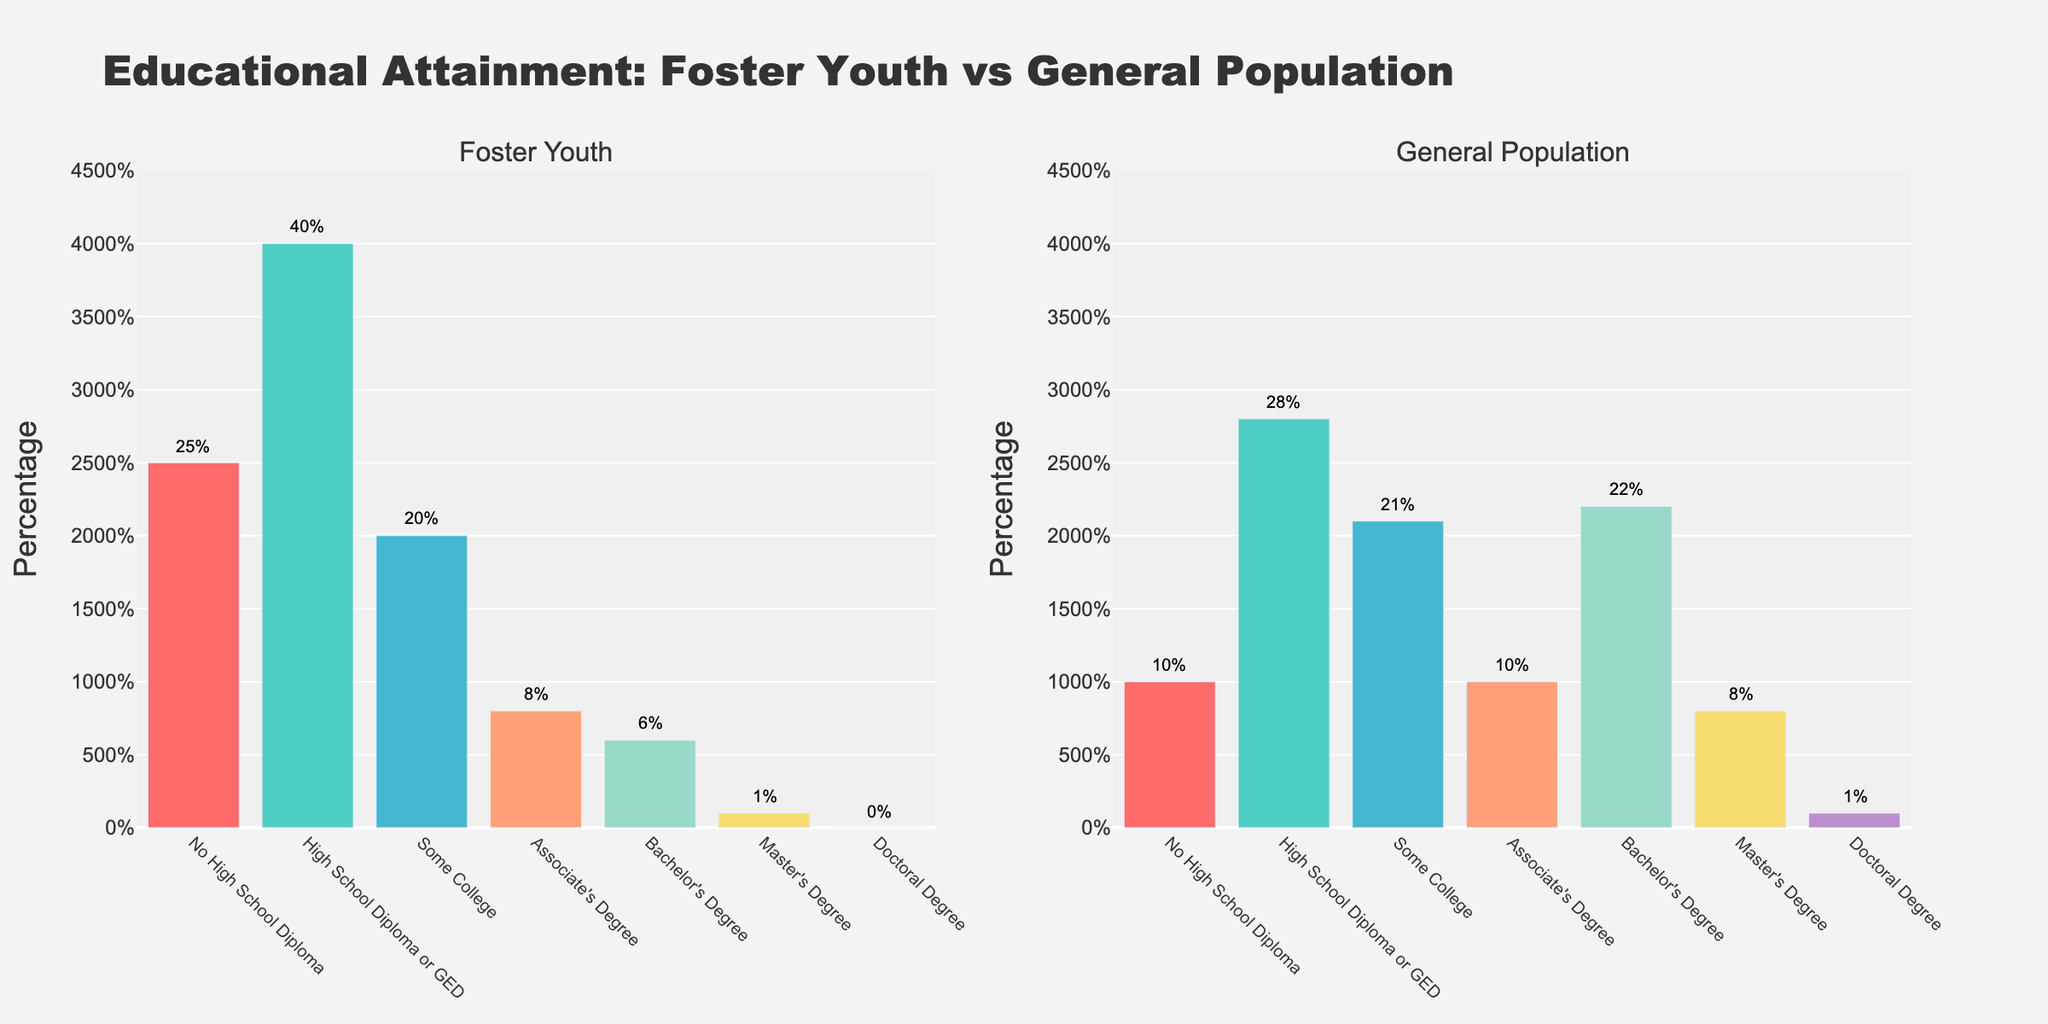What is the title of the figure? The title of the figure is displayed at the top of the plots. It reads "Educational Attainment: Foster Youth vs General Population".
Answer: Educational Attainment: Foster Youth vs General Population How many educational attainment levels are shown in the figure? The figure shows bars corresponding to the different educational levels on the x-axis. Counting them gives: "No High School Diploma", "High School Diploma or GED", "Some College", "Associate's Degree", "Bachelor's Degree", "Master's Degree", and "Doctoral Degree".
Answer: 7 Which educational level has the highest percentage among Foster Youth? By looking at the height of the bars in the "Foster Youth" plot, the tallest bar corresponds to "High School Diploma or GED".
Answer: High School Diploma or GED How does the percentage of Foster Youth with a Bachelor's Degree compare to the General Population? By comparing the heights of the bars for "Bachelor's Degree" in both plots, the bar for Foster Youth is significantly shorter (6%) than the bar for the General Population (22%).
Answer: Foster Youth has a lower percentage (6%) compared to the General Population (22%) What is the percentage difference between Foster Youth and General Population for the "Some College" level? The percentage for Foster Youth is 20%, and for the General Population it is 21%. The difference is calculated as 21% - 20% = 1%.
Answer: 1% Which group has a higher percentage of individuals with "No High School Diploma"? Comparing the bars for "No High School Diploma" in both plots shows that the bar for Foster Youth (25%) is much higher than that for the General Population (10%).
Answer: Foster Youth What is the combined percentage of Foster Youth with "Master’s Degree" and "Doctoral Degree"? Adding the percentages for "Master's Degree" (1%) and "Doctoral Degree" (0%) gives a total of 1% + 0% = 1%.
Answer: 1% Which educational level shows the least difference in percentage between Foster Youth and the General Population? Evaluating each educational level, "Some College" shows a minimal difference, with Foster Youth at 20% and General Population at 21%, giving a difference of just 1%.
Answer: Some College What is the percentage of the General Population with a High School Diploma or GED? Referencing the respective bar in the "General Population" plot, the percentage is shown directly above the bar, which is 28%.
Answer: 28% What educational levels show a higher percentage for the General Population than for Foster Youth? By comparing the heights of bars at each educational level: "Bachelor's Degree" (22% vs 6%), "Master's Degree" (8% vs 1%), and "Doctoral Degree" (1% vs 0%) are higher in the General Population.
Answer: Bachelor's Degree, Master's Degree, Doctoral Degree 